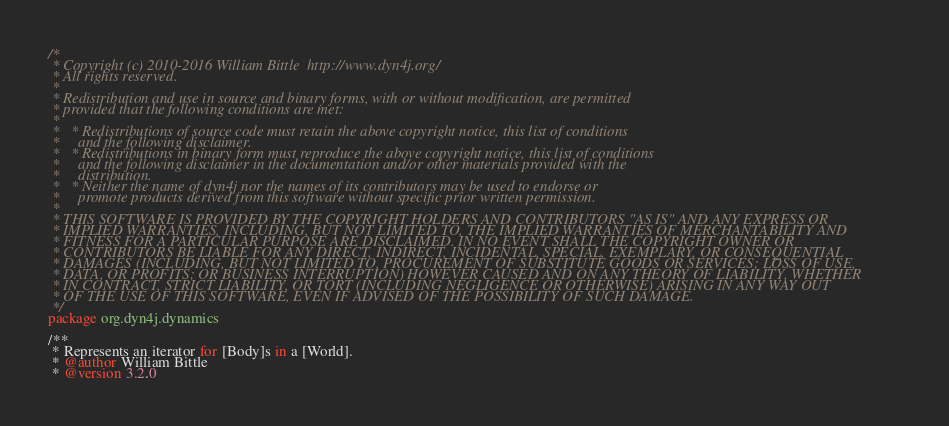<code> <loc_0><loc_0><loc_500><loc_500><_Kotlin_>/*
 * Copyright (c) 2010-2016 William Bittle  http://www.dyn4j.org/
 * All rights reserved.
 * 
 * Redistribution and use in source and binary forms, with or without modification, are permitted 
 * provided that the following conditions are met:
 * 
 *   * Redistributions of source code must retain the above copyright notice, this list of conditions 
 *     and the following disclaimer.
 *   * Redistributions in binary form must reproduce the above copyright notice, this list of conditions 
 *     and the following disclaimer in the documentation and/or other materials provided with the 
 *     distribution.
 *   * Neither the name of dyn4j nor the names of its contributors may be used to endorse or 
 *     promote products derived from this software without specific prior written permission.
 * 
 * THIS SOFTWARE IS PROVIDED BY THE COPYRIGHT HOLDERS AND CONTRIBUTORS "AS IS" AND ANY EXPRESS OR 
 * IMPLIED WARRANTIES, INCLUDING, BUT NOT LIMITED TO, THE IMPLIED WARRANTIES OF MERCHANTABILITY AND 
 * FITNESS FOR A PARTICULAR PURPOSE ARE DISCLAIMED. IN NO EVENT SHALL THE COPYRIGHT OWNER OR 
 * CONTRIBUTORS BE LIABLE FOR ANY DIRECT, INDIRECT, INCIDENTAL, SPECIAL, EXEMPLARY, OR CONSEQUENTIAL 
 * DAMAGES (INCLUDING, BUT NOT LIMITED TO, PROCUREMENT OF SUBSTITUTE GOODS OR SERVICES; LOSS OF USE, 
 * DATA, OR PROFITS; OR BUSINESS INTERRUPTION) HOWEVER CAUSED AND ON ANY THEORY OF LIABILITY, WHETHER 
 * IN CONTRACT, STRICT LIABILITY, OR TORT (INCLUDING NEGLIGENCE OR OTHERWISE) ARISING IN ANY WAY OUT 
 * OF THE USE OF THIS SOFTWARE, EVEN IF ADVISED OF THE POSSIBILITY OF SUCH DAMAGE.
 */
package org.dyn4j.dynamics

/**
 * Represents an iterator for [Body]s in a [World].
 * @author William Bittle
 * @version 3.2.0</code> 